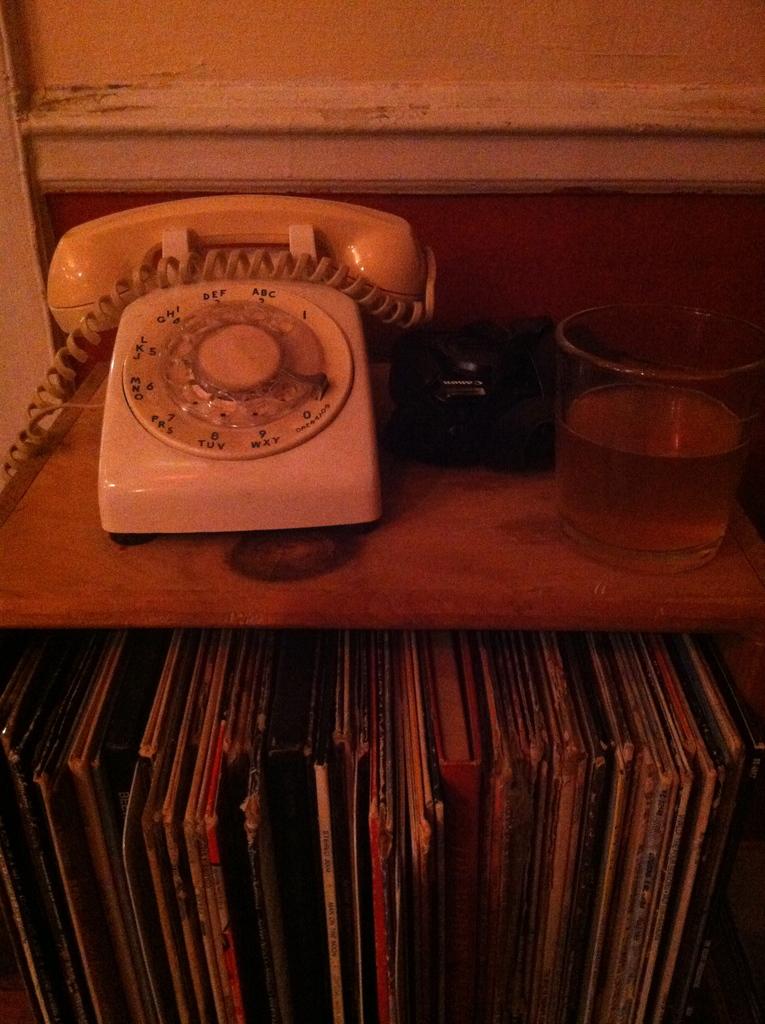Is this a home phone?
Give a very brief answer. Answering does not require reading text in the image. Is this a rotary or button phone?
Give a very brief answer. Answering does not require reading text in the image. 